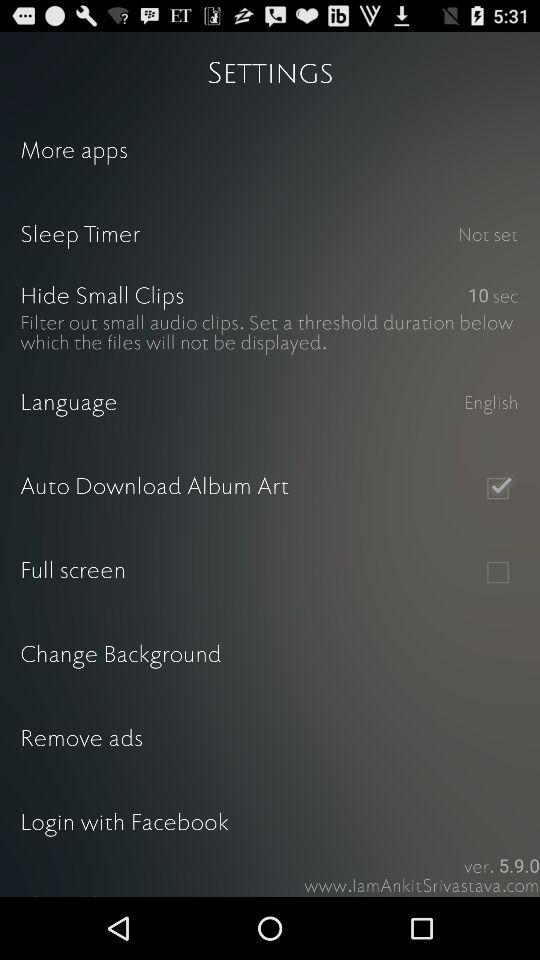What is the current status of "Full screen"? The current status of "Full screen" is "off". 